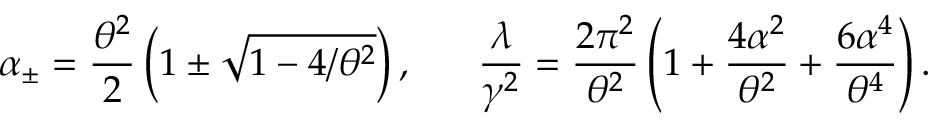<formula> <loc_0><loc_0><loc_500><loc_500>\alpha _ { \pm } = \frac { \theta ^ { 2 } } { 2 } \left ( 1 \pm \sqrt { 1 - 4 / \theta ^ { 2 } } \right ) , \quad \ \frac { \lambda } { \gamma ^ { 2 } } = \frac { 2 \pi ^ { 2 } } { \theta ^ { 2 } } \left ( 1 + \frac { 4 \alpha ^ { 2 } } { \theta ^ { 2 } } + \frac { 6 \alpha ^ { 4 } } { \theta ^ { 4 } } \right ) .</formula> 